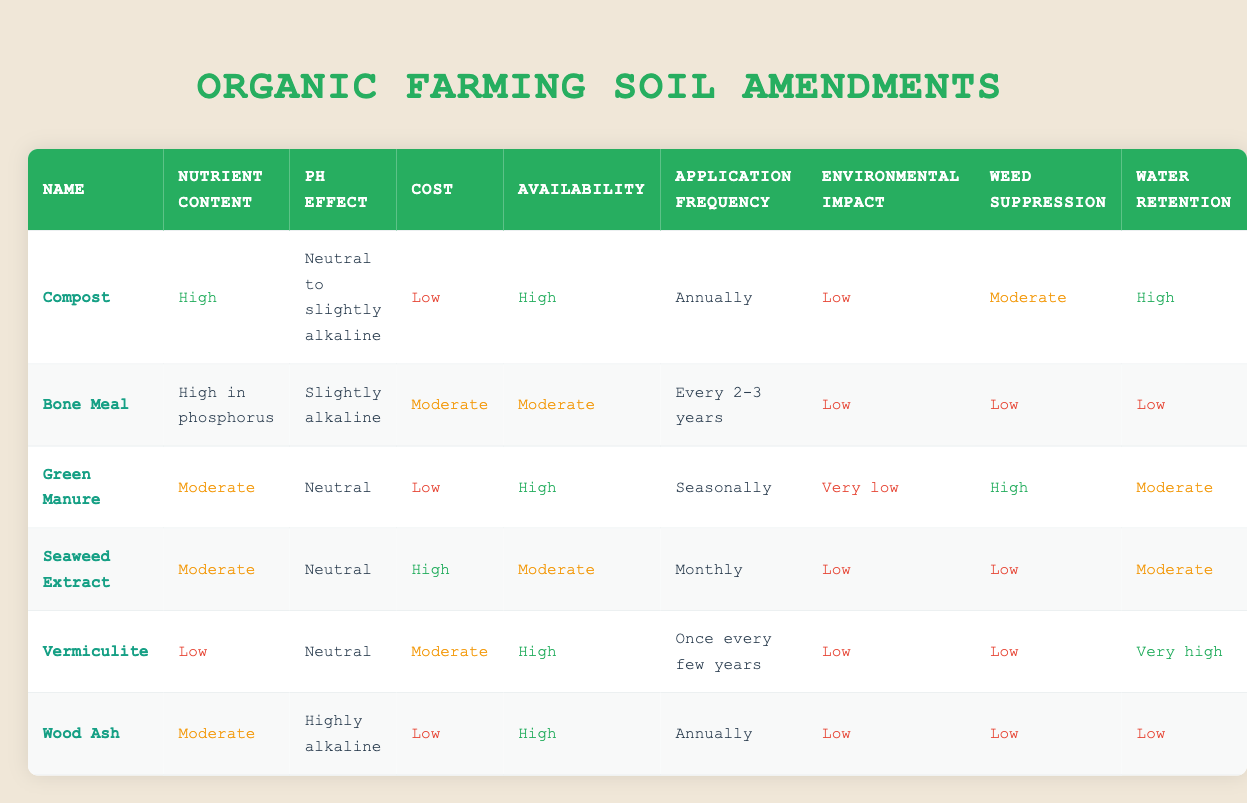What is the cost of Compost? The cost of Compost is listed as "Low" in the table.
Answer: Low Which soil amendment has the highest weed suppression? Green Manure is indicated to have "High" weed suppression, which is the highest compared to others like Compost (Moderate), Bone Meal (Low), and others.
Answer: Green Manure How often should Seaweed Extract be applied? The application frequency for Seaweed Extract is stated as "Monthly" in the table.
Answer: Monthly Which soil amendment has a "Very high" water retention? Vermiculite is noted for having "Very high" water retention, which distinguishes it from the other amendments listed.
Answer: Vermiculite Is Bone Meal available in high amounts? The availability of Bone Meal is categorized as "Moderate," not high, so the answer is no.
Answer: No What is the average environmental impact rating of the soil amendments listed? The environmental impact ratings are categorized as Low (Compost, Bone Meal, Seaweed Extract, Vermiculite, Wood Ash), Very low (Green Manure), and Low (overall average can be inferred as dominating by Low). Therefore, averaging suggests a predominantly low impact overall.
Answer: Low Which soil amendment has the lowest nutrient content? Vermiculite is the only amendment classified as having "Low" nutrient content, while others rank higher.
Answer: Vermiculite Is the cost of Green Manure the same as that of Wood Ash? The cost of Green Manure is "Low," while the cost of Wood Ash is also "Low," making them equal in cost.
Answer: Yes How many soil amendments require annual application? The table states that both Compost and Wood Ash require annual application, making the total count two amendments.
Answer: 2 